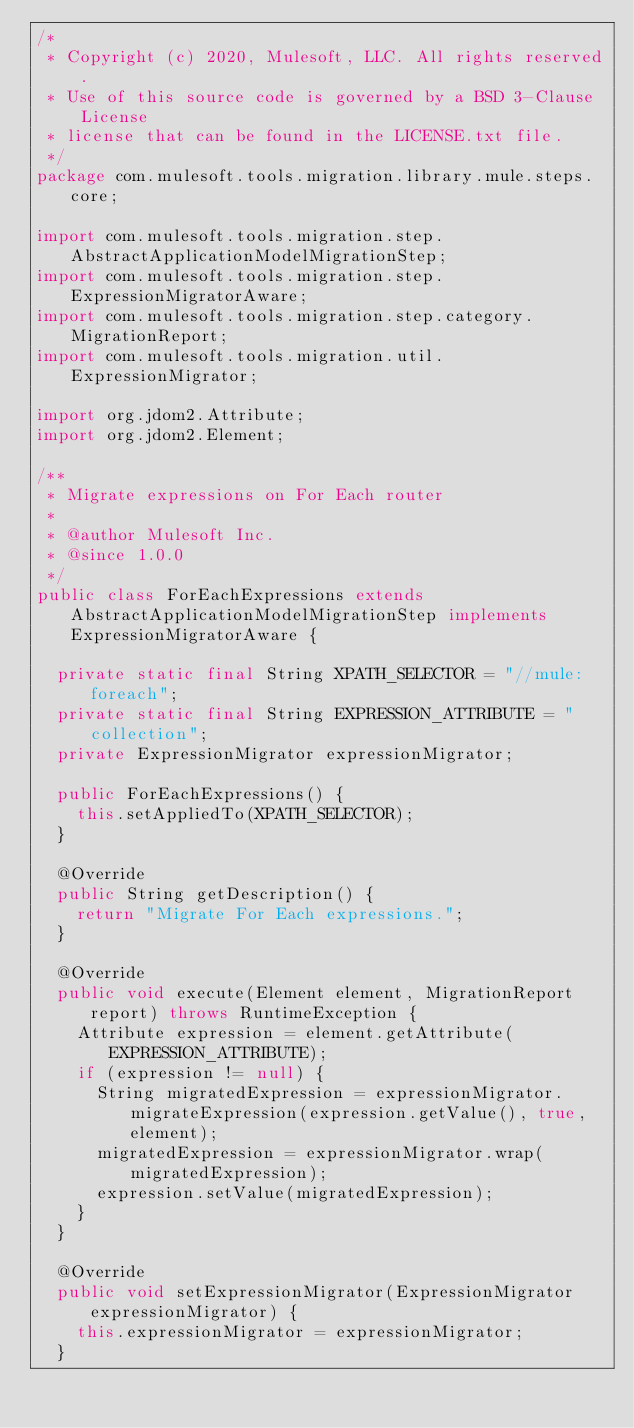Convert code to text. <code><loc_0><loc_0><loc_500><loc_500><_Java_>/*
 * Copyright (c) 2020, Mulesoft, LLC. All rights reserved.
 * Use of this source code is governed by a BSD 3-Clause License
 * license that can be found in the LICENSE.txt file.
 */
package com.mulesoft.tools.migration.library.mule.steps.core;

import com.mulesoft.tools.migration.step.AbstractApplicationModelMigrationStep;
import com.mulesoft.tools.migration.step.ExpressionMigratorAware;
import com.mulesoft.tools.migration.step.category.MigrationReport;
import com.mulesoft.tools.migration.util.ExpressionMigrator;

import org.jdom2.Attribute;
import org.jdom2.Element;

/**
 * Migrate expressions on For Each router
 *
 * @author Mulesoft Inc.
 * @since 1.0.0
 */
public class ForEachExpressions extends AbstractApplicationModelMigrationStep implements ExpressionMigratorAware {

  private static final String XPATH_SELECTOR = "//mule:foreach";
  private static final String EXPRESSION_ATTRIBUTE = "collection";
  private ExpressionMigrator expressionMigrator;

  public ForEachExpressions() {
    this.setAppliedTo(XPATH_SELECTOR);
  }

  @Override
  public String getDescription() {
    return "Migrate For Each expressions.";
  }

  @Override
  public void execute(Element element, MigrationReport report) throws RuntimeException {
    Attribute expression = element.getAttribute(EXPRESSION_ATTRIBUTE);
    if (expression != null) {
      String migratedExpression = expressionMigrator.migrateExpression(expression.getValue(), true, element);
      migratedExpression = expressionMigrator.wrap(migratedExpression);
      expression.setValue(migratedExpression);
    }
  }

  @Override
  public void setExpressionMigrator(ExpressionMigrator expressionMigrator) {
    this.expressionMigrator = expressionMigrator;
  }
</code> 